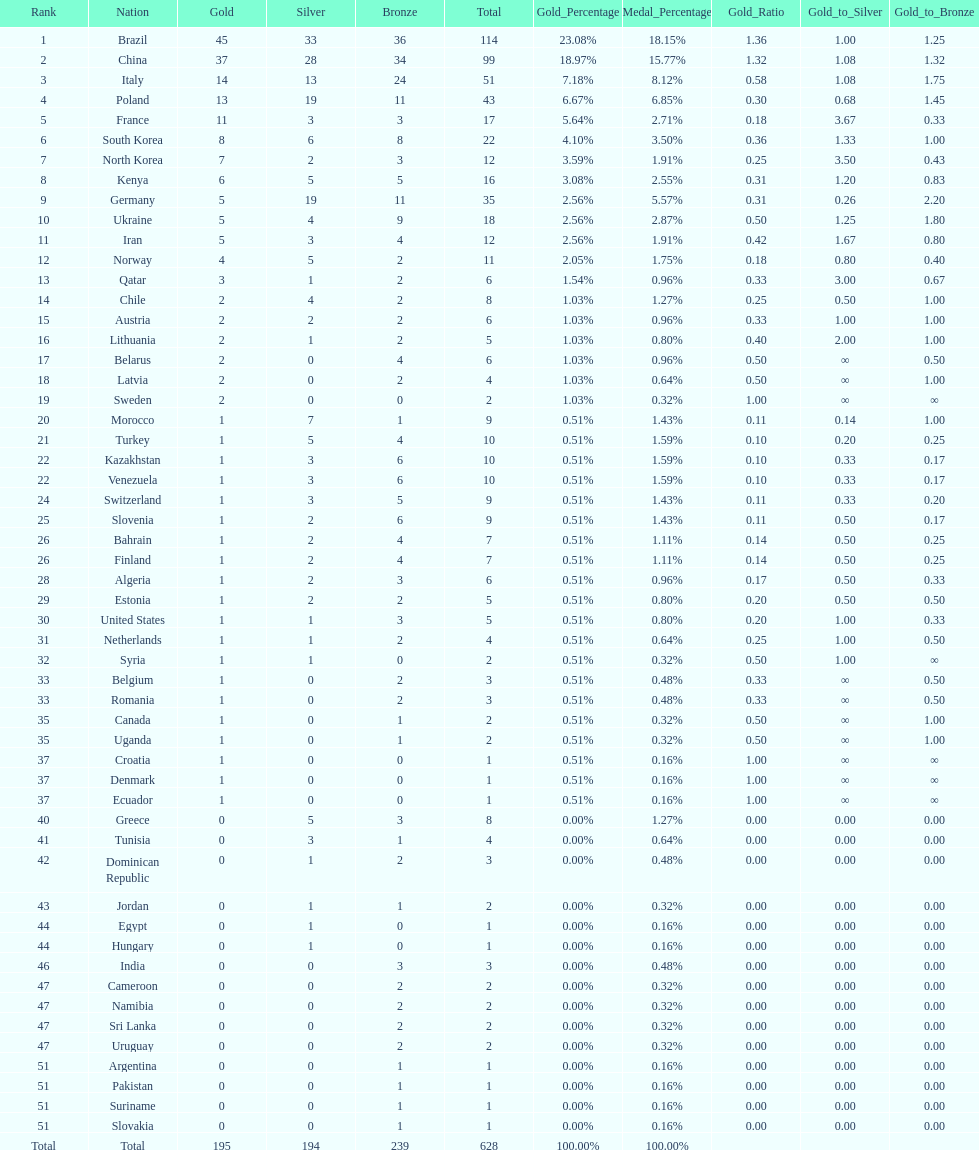What is the total number of medals between south korea, north korea, sweden, and brazil? 150. 